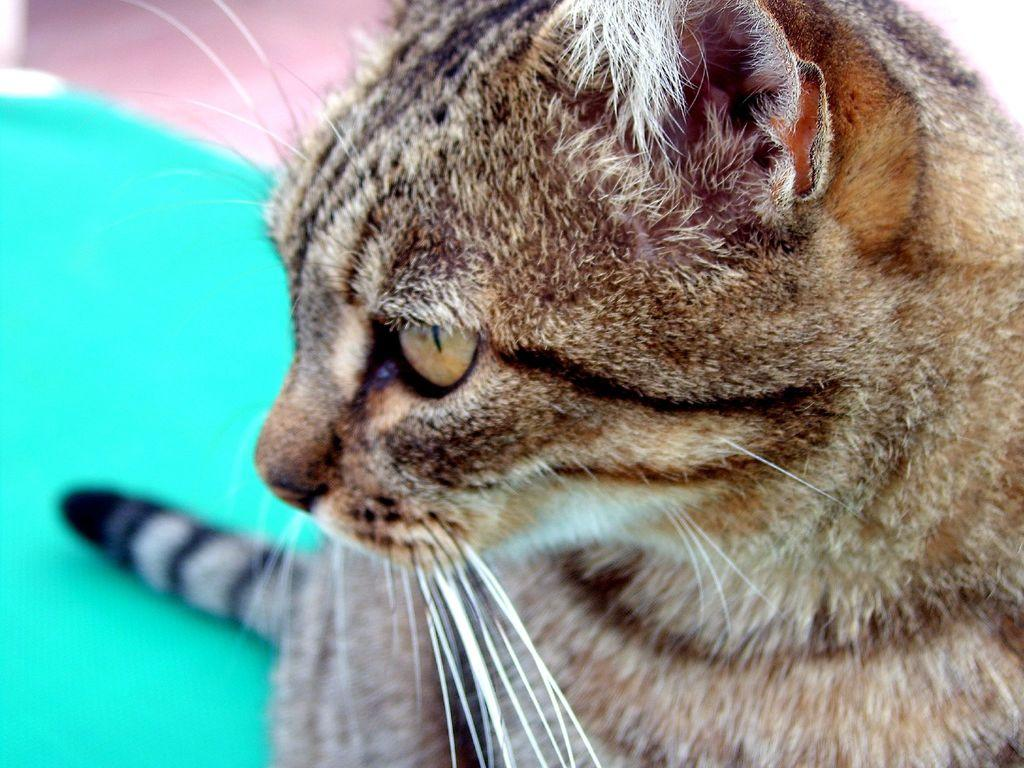What animal is present in the image? There is a cat in the image. Where is the cat located in the image? The cat is on the left side of the image. What color is the area where the cat is located? The cat is in a green color area. How would you describe the background of the image? The background of the image is blurred. What type of beef is being sold at the market in the image? There is no mention of a market or beef in the image; it features a cat in a green color area with a blurred background. 